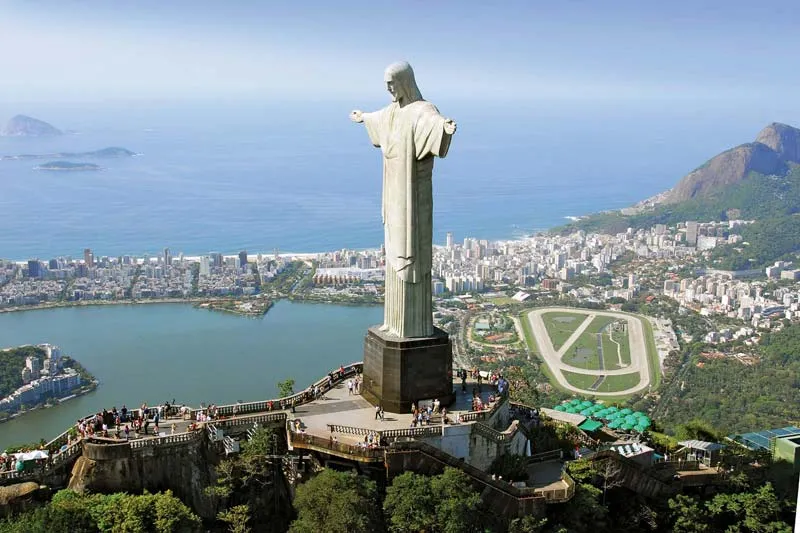Can you talk about the engineering and construction challenges faced during the building of the statue? Building the Christ the Redeemer statue posed several engineering and logistical challenges. Constructed between 1922 and 1931, the statue was made using reinforced concrete and soapstone, materials chosen for their sturdiness and weather resistance. Transportation of these materials up the steep slope of Corcovado mountain required the development of a railway system. Additionally, the statue's remote location and height necessitated precise engineering to ensure its stability against the region's frequent strong winds and rainstorms. 